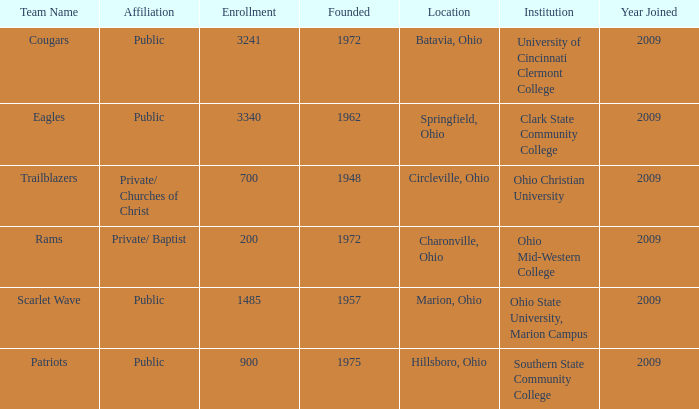What is the affiliation when the institution was ohio christian university? Private/ Churches of Christ. 